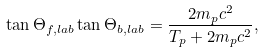<formula> <loc_0><loc_0><loc_500><loc_500>\tan \Theta _ { f , l a b } \tan \Theta _ { b , l a b } = \frac { 2 m _ { p } c ^ { 2 } } { T _ { p } + 2 m _ { p } c ^ { 2 } } ,</formula> 